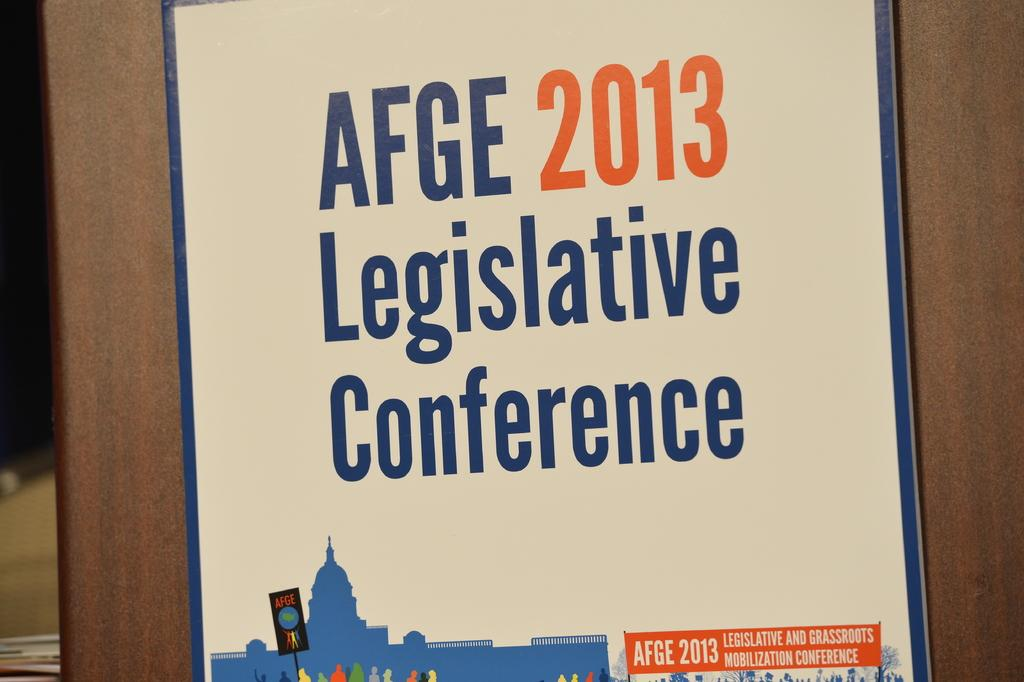<image>
Relay a brief, clear account of the picture shown. a page on a counter that says 'afge 2013' on it 